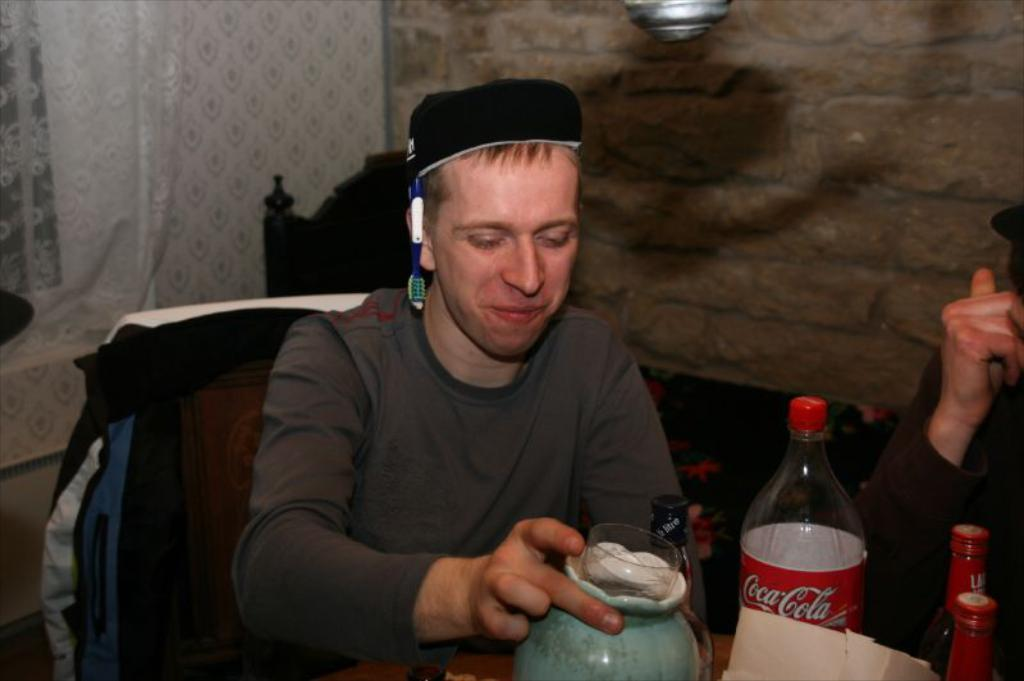What is the main subject in the image? There is a man in the image. What is the man doing in the image? The man is sitting on a chair. What is the man holding in the image? The man is holding a bottle. What is the man wearing in the image? The man is wearing a t-shirt. What is visible behind the man in the image? There is a wall behind the man. What is present on the left side of the image? There is a curtain on the left side of the image. What type of rat can be seen wearing a boot in the image? There is no rat or boot present in the image; it features a man sitting on a chair holding a bottle. 